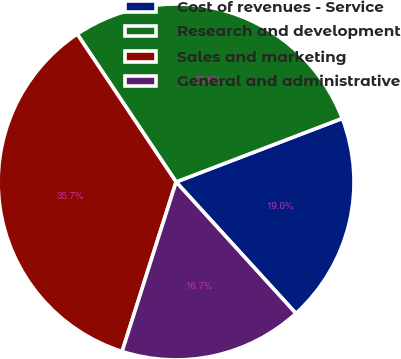<chart> <loc_0><loc_0><loc_500><loc_500><pie_chart><fcel>Cost of revenues - Service<fcel>Research and development<fcel>Sales and marketing<fcel>General and administrative<nl><fcel>19.05%<fcel>28.57%<fcel>35.71%<fcel>16.67%<nl></chart> 